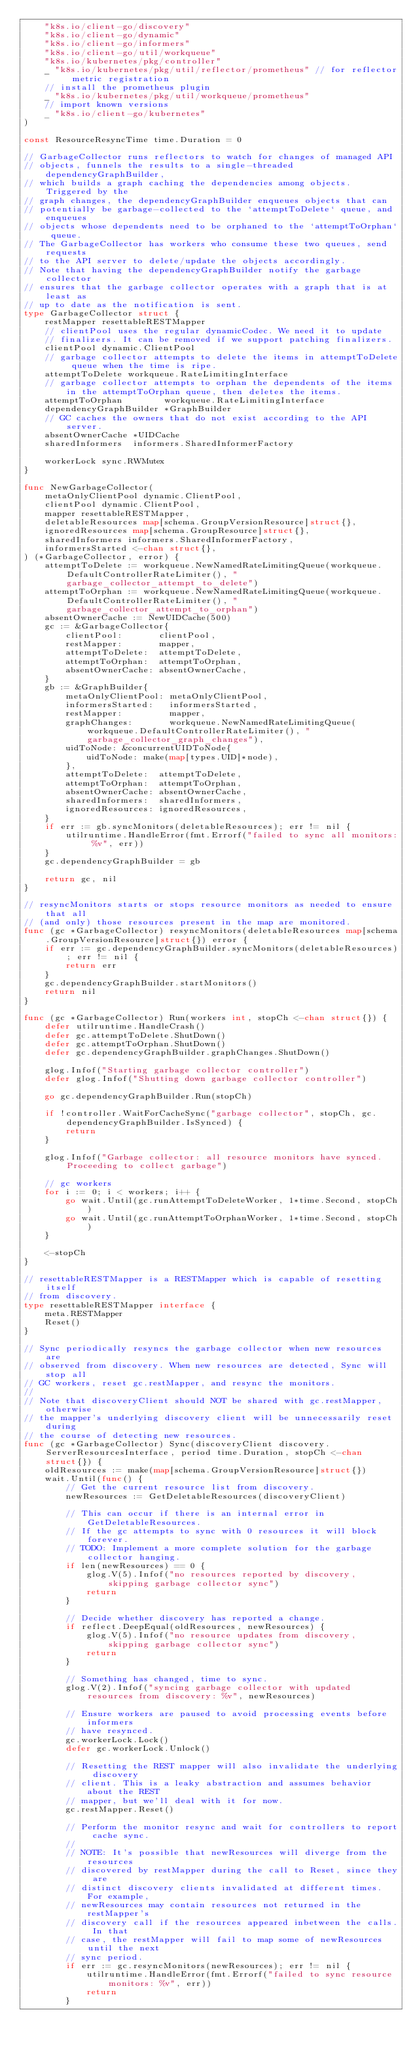<code> <loc_0><loc_0><loc_500><loc_500><_Go_>	"k8s.io/client-go/discovery"
	"k8s.io/client-go/dynamic"
	"k8s.io/client-go/informers"
	"k8s.io/client-go/util/workqueue"
	"k8s.io/kubernetes/pkg/controller"
	_ "k8s.io/kubernetes/pkg/util/reflector/prometheus" // for reflector metric registration
	// install the prometheus plugin
	_ "k8s.io/kubernetes/pkg/util/workqueue/prometheus"
	// import known versions
	_ "k8s.io/client-go/kubernetes"
)

const ResourceResyncTime time.Duration = 0

// GarbageCollector runs reflectors to watch for changes of managed API
// objects, funnels the results to a single-threaded dependencyGraphBuilder,
// which builds a graph caching the dependencies among objects. Triggered by the
// graph changes, the dependencyGraphBuilder enqueues objects that can
// potentially be garbage-collected to the `attemptToDelete` queue, and enqueues
// objects whose dependents need to be orphaned to the `attemptToOrphan` queue.
// The GarbageCollector has workers who consume these two queues, send requests
// to the API server to delete/update the objects accordingly.
// Note that having the dependencyGraphBuilder notify the garbage collector
// ensures that the garbage collector operates with a graph that is at least as
// up to date as the notification is sent.
type GarbageCollector struct {
	restMapper resettableRESTMapper
	// clientPool uses the regular dynamicCodec. We need it to update
	// finalizers. It can be removed if we support patching finalizers.
	clientPool dynamic.ClientPool
	// garbage collector attempts to delete the items in attemptToDelete queue when the time is ripe.
	attemptToDelete workqueue.RateLimitingInterface
	// garbage collector attempts to orphan the dependents of the items in the attemptToOrphan queue, then deletes the items.
	attemptToOrphan        workqueue.RateLimitingInterface
	dependencyGraphBuilder *GraphBuilder
	// GC caches the owners that do not exist according to the API server.
	absentOwnerCache *UIDCache
	sharedInformers  informers.SharedInformerFactory

	workerLock sync.RWMutex
}

func NewGarbageCollector(
	metaOnlyClientPool dynamic.ClientPool,
	clientPool dynamic.ClientPool,
	mapper resettableRESTMapper,
	deletableResources map[schema.GroupVersionResource]struct{},
	ignoredResources map[schema.GroupResource]struct{},
	sharedInformers informers.SharedInformerFactory,
	informersStarted <-chan struct{},
) (*GarbageCollector, error) {
	attemptToDelete := workqueue.NewNamedRateLimitingQueue(workqueue.DefaultControllerRateLimiter(), "garbage_collector_attempt_to_delete")
	attemptToOrphan := workqueue.NewNamedRateLimitingQueue(workqueue.DefaultControllerRateLimiter(), "garbage_collector_attempt_to_orphan")
	absentOwnerCache := NewUIDCache(500)
	gc := &GarbageCollector{
		clientPool:       clientPool,
		restMapper:       mapper,
		attemptToDelete:  attemptToDelete,
		attemptToOrphan:  attemptToOrphan,
		absentOwnerCache: absentOwnerCache,
	}
	gb := &GraphBuilder{
		metaOnlyClientPool: metaOnlyClientPool,
		informersStarted:   informersStarted,
		restMapper:         mapper,
		graphChanges:       workqueue.NewNamedRateLimitingQueue(workqueue.DefaultControllerRateLimiter(), "garbage_collector_graph_changes"),
		uidToNode: &concurrentUIDToNode{
			uidToNode: make(map[types.UID]*node),
		},
		attemptToDelete:  attemptToDelete,
		attemptToOrphan:  attemptToOrphan,
		absentOwnerCache: absentOwnerCache,
		sharedInformers:  sharedInformers,
		ignoredResources: ignoredResources,
	}
	if err := gb.syncMonitors(deletableResources); err != nil {
		utilruntime.HandleError(fmt.Errorf("failed to sync all monitors: %v", err))
	}
	gc.dependencyGraphBuilder = gb

	return gc, nil
}

// resyncMonitors starts or stops resource monitors as needed to ensure that all
// (and only) those resources present in the map are monitored.
func (gc *GarbageCollector) resyncMonitors(deletableResources map[schema.GroupVersionResource]struct{}) error {
	if err := gc.dependencyGraphBuilder.syncMonitors(deletableResources); err != nil {
		return err
	}
	gc.dependencyGraphBuilder.startMonitors()
	return nil
}

func (gc *GarbageCollector) Run(workers int, stopCh <-chan struct{}) {
	defer utilruntime.HandleCrash()
	defer gc.attemptToDelete.ShutDown()
	defer gc.attemptToOrphan.ShutDown()
	defer gc.dependencyGraphBuilder.graphChanges.ShutDown()

	glog.Infof("Starting garbage collector controller")
	defer glog.Infof("Shutting down garbage collector controller")

	go gc.dependencyGraphBuilder.Run(stopCh)

	if !controller.WaitForCacheSync("garbage collector", stopCh, gc.dependencyGraphBuilder.IsSynced) {
		return
	}

	glog.Infof("Garbage collector: all resource monitors have synced. Proceeding to collect garbage")

	// gc workers
	for i := 0; i < workers; i++ {
		go wait.Until(gc.runAttemptToDeleteWorker, 1*time.Second, stopCh)
		go wait.Until(gc.runAttemptToOrphanWorker, 1*time.Second, stopCh)
	}

	<-stopCh
}

// resettableRESTMapper is a RESTMapper which is capable of resetting itself
// from discovery.
type resettableRESTMapper interface {
	meta.RESTMapper
	Reset()
}

// Sync periodically resyncs the garbage collector when new resources are
// observed from discovery. When new resources are detected, Sync will stop all
// GC workers, reset gc.restMapper, and resync the monitors.
//
// Note that discoveryClient should NOT be shared with gc.restMapper, otherwise
// the mapper's underlying discovery client will be unnecessarily reset during
// the course of detecting new resources.
func (gc *GarbageCollector) Sync(discoveryClient discovery.ServerResourcesInterface, period time.Duration, stopCh <-chan struct{}) {
	oldResources := make(map[schema.GroupVersionResource]struct{})
	wait.Until(func() {
		// Get the current resource list from discovery.
		newResources := GetDeletableResources(discoveryClient)

		// This can occur if there is an internal error in GetDeletableResources.
		// If the gc attempts to sync with 0 resources it will block forever.
		// TODO: Implement a more complete solution for the garbage collector hanging.
		if len(newResources) == 0 {
			glog.V(5).Infof("no resources reported by discovery, skipping garbage collector sync")
			return
		}

		// Decide whether discovery has reported a change.
		if reflect.DeepEqual(oldResources, newResources) {
			glog.V(5).Infof("no resource updates from discovery, skipping garbage collector sync")
			return
		}

		// Something has changed, time to sync.
		glog.V(2).Infof("syncing garbage collector with updated resources from discovery: %v", newResources)

		// Ensure workers are paused to avoid processing events before informers
		// have resynced.
		gc.workerLock.Lock()
		defer gc.workerLock.Unlock()

		// Resetting the REST mapper will also invalidate the underlying discovery
		// client. This is a leaky abstraction and assumes behavior about the REST
		// mapper, but we'll deal with it for now.
		gc.restMapper.Reset()

		// Perform the monitor resync and wait for controllers to report cache sync.
		//
		// NOTE: It's possible that newResources will diverge from the resources
		// discovered by restMapper during the call to Reset, since they are
		// distinct discovery clients invalidated at different times. For example,
		// newResources may contain resources not returned in the restMapper's
		// discovery call if the resources appeared inbetween the calls. In that
		// case, the restMapper will fail to map some of newResources until the next
		// sync period.
		if err := gc.resyncMonitors(newResources); err != nil {
			utilruntime.HandleError(fmt.Errorf("failed to sync resource monitors: %v", err))
			return
		}</code> 